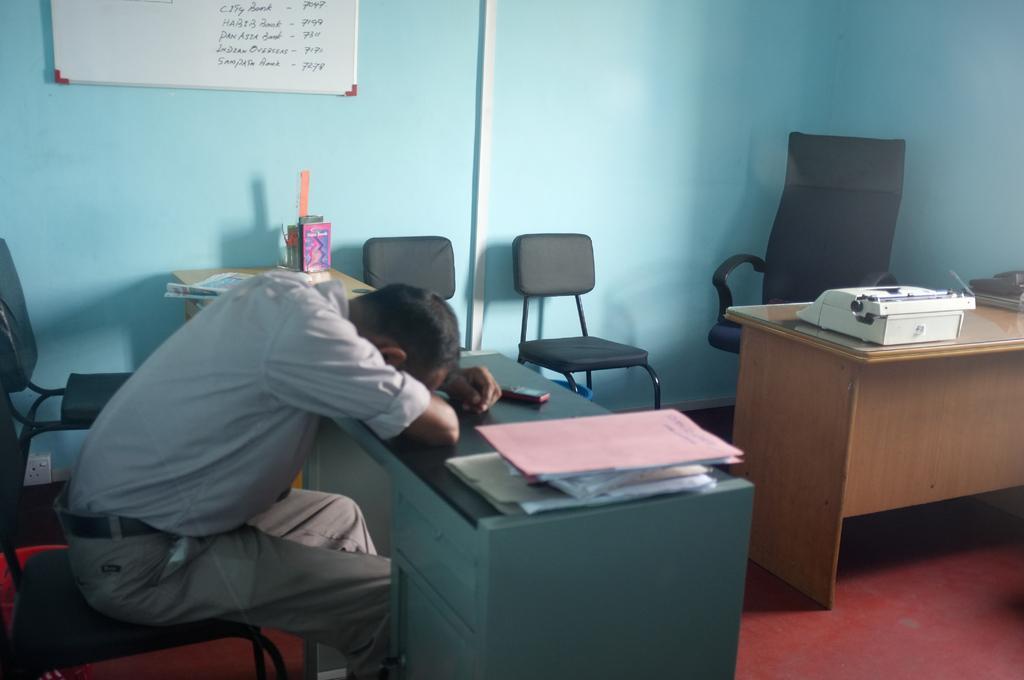Please provide a concise description of this image. In this image I can see the person sitting and I can see few papers, files, mobile on the table. In the background I can see few chairs and I can also see the board attached to the wall and the wall is in green color. 